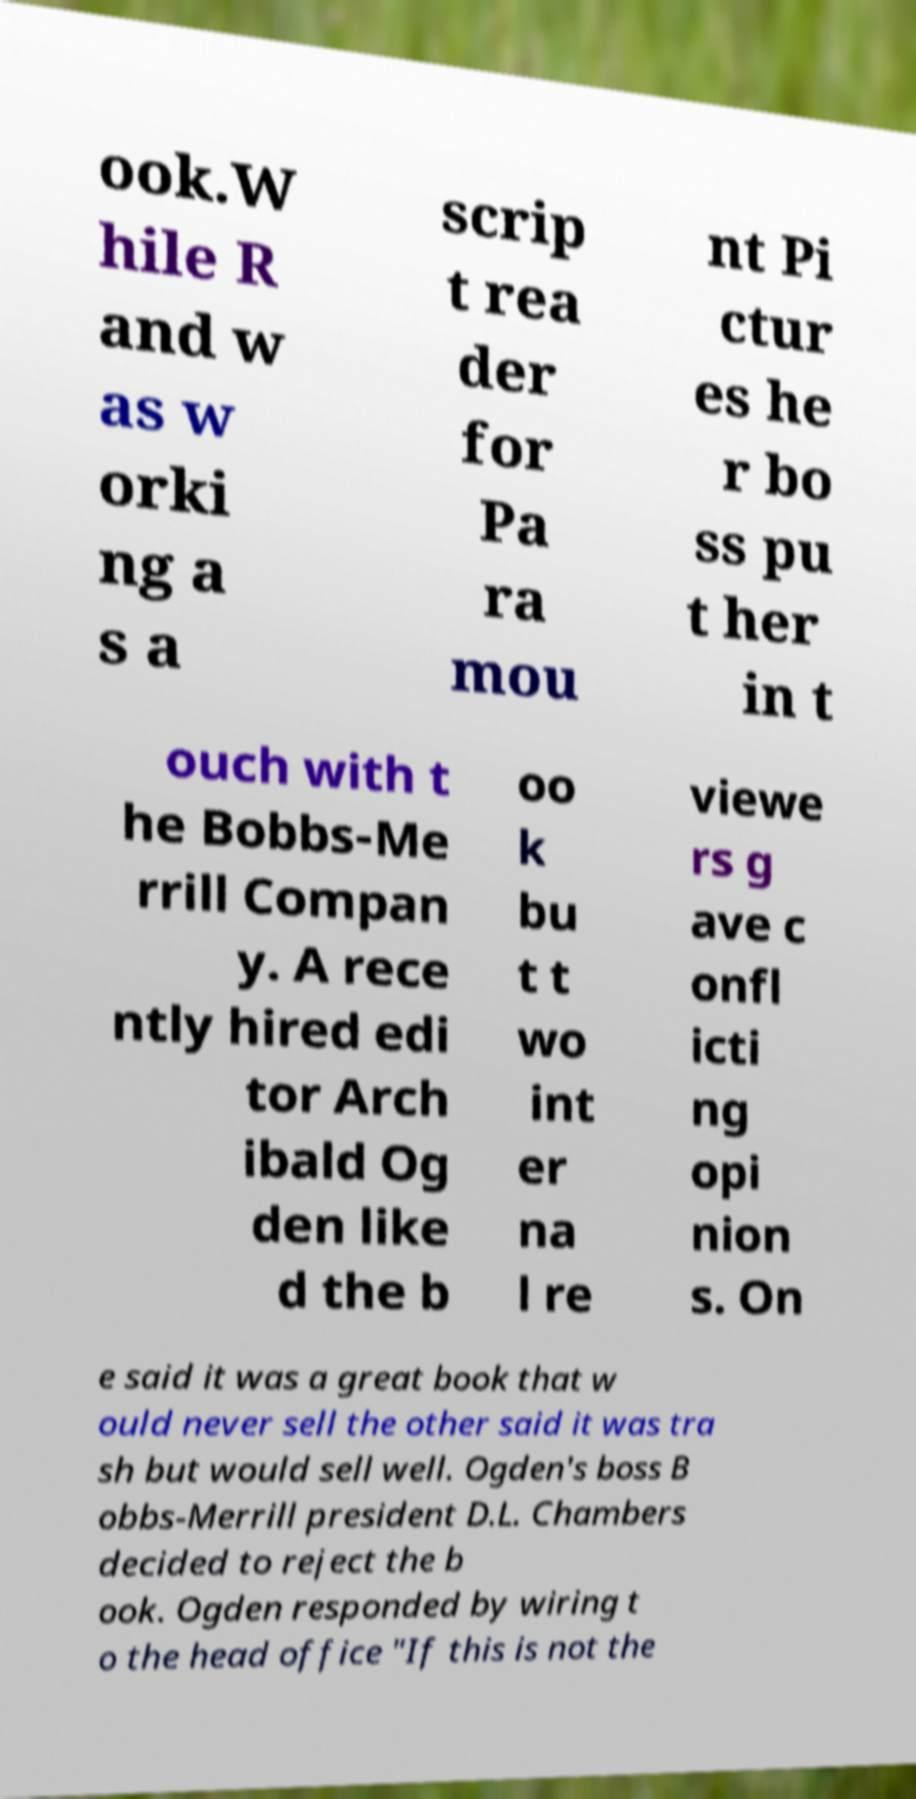Could you extract and type out the text from this image? ook.W hile R and w as w orki ng a s a scrip t rea der for Pa ra mou nt Pi ctur es he r bo ss pu t her in t ouch with t he Bobbs-Me rrill Compan y. A rece ntly hired edi tor Arch ibald Og den like d the b oo k bu t t wo int er na l re viewe rs g ave c onfl icti ng opi nion s. On e said it was a great book that w ould never sell the other said it was tra sh but would sell well. Ogden's boss B obbs-Merrill president D.L. Chambers decided to reject the b ook. Ogden responded by wiring t o the head office "If this is not the 